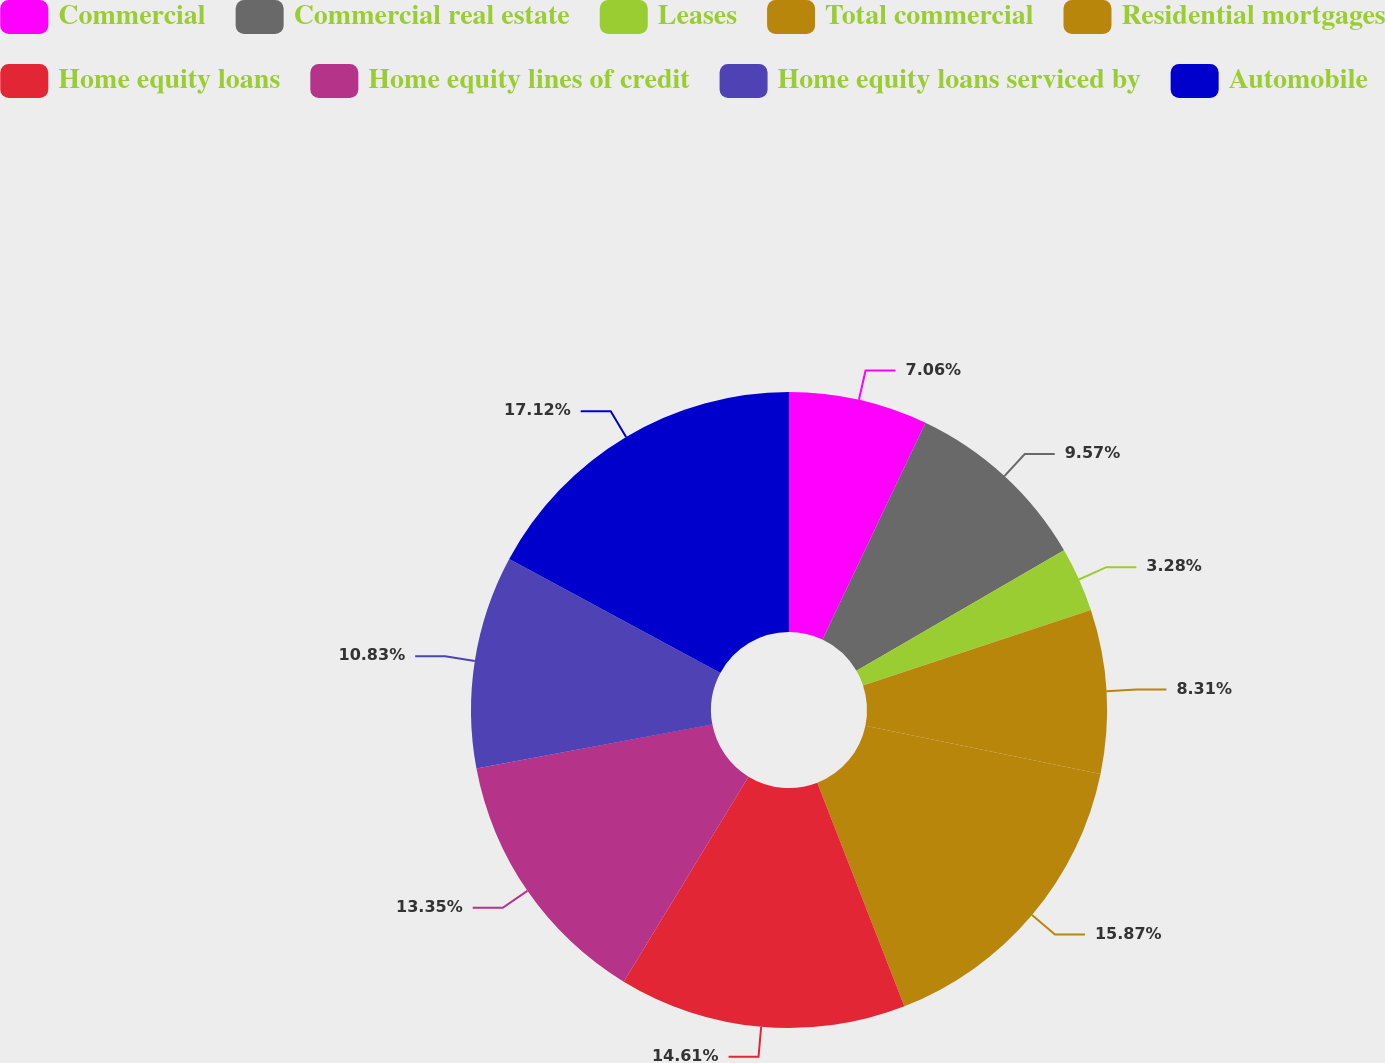Convert chart to OTSL. <chart><loc_0><loc_0><loc_500><loc_500><pie_chart><fcel>Commercial<fcel>Commercial real estate<fcel>Leases<fcel>Total commercial<fcel>Residential mortgages<fcel>Home equity loans<fcel>Home equity lines of credit<fcel>Home equity loans serviced by<fcel>Automobile<nl><fcel>7.06%<fcel>9.57%<fcel>3.28%<fcel>8.31%<fcel>15.87%<fcel>14.61%<fcel>13.35%<fcel>10.83%<fcel>17.12%<nl></chart> 